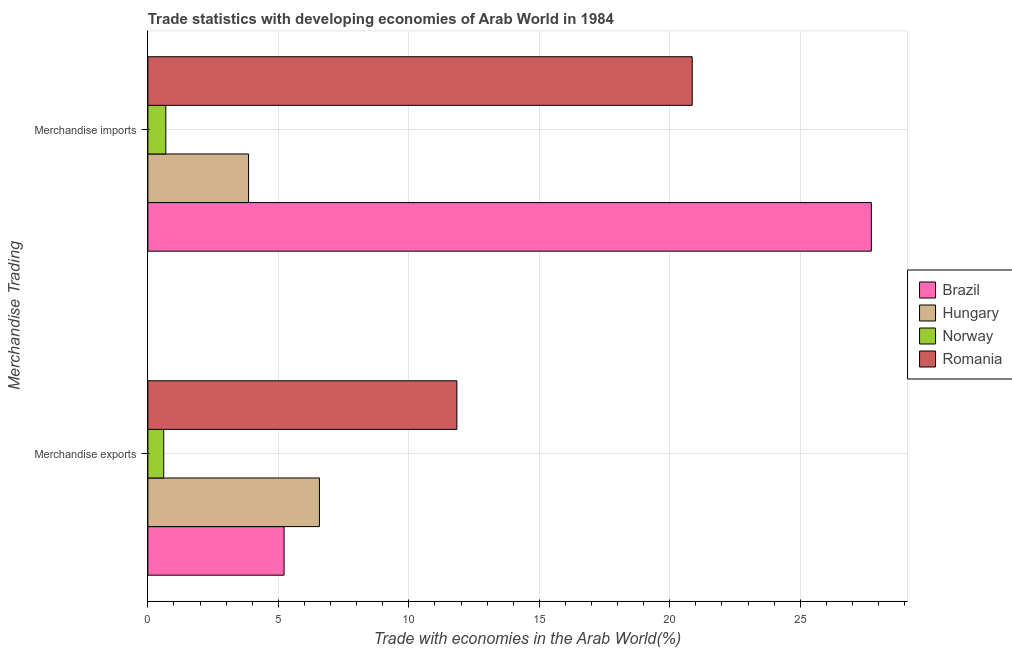How many different coloured bars are there?
Keep it short and to the point. 4. How many groups of bars are there?
Ensure brevity in your answer.  2. Are the number of bars on each tick of the Y-axis equal?
Give a very brief answer. Yes. How many bars are there on the 1st tick from the top?
Provide a succinct answer. 4. How many bars are there on the 1st tick from the bottom?
Provide a succinct answer. 4. What is the label of the 1st group of bars from the top?
Your answer should be very brief. Merchandise imports. What is the merchandise imports in Hungary?
Your answer should be very brief. 3.86. Across all countries, what is the maximum merchandise exports?
Your response must be concise. 11.84. Across all countries, what is the minimum merchandise exports?
Offer a terse response. 0.61. In which country was the merchandise imports maximum?
Offer a very short reply. Brazil. What is the total merchandise exports in the graph?
Keep it short and to the point. 24.25. What is the difference between the merchandise exports in Romania and that in Norway?
Your response must be concise. 11.23. What is the difference between the merchandise exports in Romania and the merchandise imports in Norway?
Make the answer very short. 11.16. What is the average merchandise exports per country?
Make the answer very short. 6.06. What is the difference between the merchandise exports and merchandise imports in Hungary?
Make the answer very short. 2.72. In how many countries, is the merchandise exports greater than 2 %?
Your answer should be very brief. 3. What is the ratio of the merchandise exports in Hungary to that in Brazil?
Ensure brevity in your answer.  1.26. In how many countries, is the merchandise exports greater than the average merchandise exports taken over all countries?
Offer a terse response. 2. What does the 2nd bar from the bottom in Merchandise exports represents?
Provide a succinct answer. Hungary. How many bars are there?
Your answer should be very brief. 8. How many countries are there in the graph?
Your answer should be very brief. 4. What is the difference between two consecutive major ticks on the X-axis?
Keep it short and to the point. 5. Are the values on the major ticks of X-axis written in scientific E-notation?
Your response must be concise. No. Does the graph contain any zero values?
Offer a very short reply. No. Does the graph contain grids?
Offer a very short reply. Yes. Where does the legend appear in the graph?
Offer a very short reply. Center right. How are the legend labels stacked?
Offer a terse response. Vertical. What is the title of the graph?
Your answer should be compact. Trade statistics with developing economies of Arab World in 1984. Does "Chile" appear as one of the legend labels in the graph?
Offer a very short reply. No. What is the label or title of the X-axis?
Keep it short and to the point. Trade with economies in the Arab World(%). What is the label or title of the Y-axis?
Provide a short and direct response. Merchandise Trading. What is the Trade with economies in the Arab World(%) of Brazil in Merchandise exports?
Your answer should be very brief. 5.22. What is the Trade with economies in the Arab World(%) of Hungary in Merchandise exports?
Your response must be concise. 6.57. What is the Trade with economies in the Arab World(%) of Norway in Merchandise exports?
Provide a succinct answer. 0.61. What is the Trade with economies in the Arab World(%) in Romania in Merchandise exports?
Your answer should be compact. 11.84. What is the Trade with economies in the Arab World(%) of Brazil in Merchandise imports?
Your answer should be very brief. 27.73. What is the Trade with economies in the Arab World(%) of Hungary in Merchandise imports?
Ensure brevity in your answer.  3.86. What is the Trade with economies in the Arab World(%) of Norway in Merchandise imports?
Your answer should be very brief. 0.69. What is the Trade with economies in the Arab World(%) in Romania in Merchandise imports?
Keep it short and to the point. 20.86. Across all Merchandise Trading, what is the maximum Trade with economies in the Arab World(%) in Brazil?
Your response must be concise. 27.73. Across all Merchandise Trading, what is the maximum Trade with economies in the Arab World(%) of Hungary?
Your response must be concise. 6.57. Across all Merchandise Trading, what is the maximum Trade with economies in the Arab World(%) of Norway?
Ensure brevity in your answer.  0.69. Across all Merchandise Trading, what is the maximum Trade with economies in the Arab World(%) in Romania?
Your answer should be compact. 20.86. Across all Merchandise Trading, what is the minimum Trade with economies in the Arab World(%) in Brazil?
Your response must be concise. 5.22. Across all Merchandise Trading, what is the minimum Trade with economies in the Arab World(%) of Hungary?
Give a very brief answer. 3.86. Across all Merchandise Trading, what is the minimum Trade with economies in the Arab World(%) of Norway?
Ensure brevity in your answer.  0.61. Across all Merchandise Trading, what is the minimum Trade with economies in the Arab World(%) of Romania?
Ensure brevity in your answer.  11.84. What is the total Trade with economies in the Arab World(%) of Brazil in the graph?
Your answer should be very brief. 32.95. What is the total Trade with economies in the Arab World(%) of Hungary in the graph?
Offer a terse response. 10.43. What is the total Trade with economies in the Arab World(%) in Norway in the graph?
Ensure brevity in your answer.  1.3. What is the total Trade with economies in the Arab World(%) of Romania in the graph?
Your answer should be compact. 32.7. What is the difference between the Trade with economies in the Arab World(%) of Brazil in Merchandise exports and that in Merchandise imports?
Make the answer very short. -22.51. What is the difference between the Trade with economies in the Arab World(%) of Hungary in Merchandise exports and that in Merchandise imports?
Offer a terse response. 2.72. What is the difference between the Trade with economies in the Arab World(%) of Norway in Merchandise exports and that in Merchandise imports?
Your response must be concise. -0.08. What is the difference between the Trade with economies in the Arab World(%) in Romania in Merchandise exports and that in Merchandise imports?
Make the answer very short. -9.02. What is the difference between the Trade with economies in the Arab World(%) of Brazil in Merchandise exports and the Trade with economies in the Arab World(%) of Hungary in Merchandise imports?
Keep it short and to the point. 1.36. What is the difference between the Trade with economies in the Arab World(%) of Brazil in Merchandise exports and the Trade with economies in the Arab World(%) of Norway in Merchandise imports?
Keep it short and to the point. 4.53. What is the difference between the Trade with economies in the Arab World(%) in Brazil in Merchandise exports and the Trade with economies in the Arab World(%) in Romania in Merchandise imports?
Make the answer very short. -15.64. What is the difference between the Trade with economies in the Arab World(%) in Hungary in Merchandise exports and the Trade with economies in the Arab World(%) in Norway in Merchandise imports?
Provide a short and direct response. 5.89. What is the difference between the Trade with economies in the Arab World(%) of Hungary in Merchandise exports and the Trade with economies in the Arab World(%) of Romania in Merchandise imports?
Offer a very short reply. -14.29. What is the difference between the Trade with economies in the Arab World(%) in Norway in Merchandise exports and the Trade with economies in the Arab World(%) in Romania in Merchandise imports?
Your answer should be compact. -20.25. What is the average Trade with economies in the Arab World(%) in Brazil per Merchandise Trading?
Your answer should be very brief. 16.47. What is the average Trade with economies in the Arab World(%) of Hungary per Merchandise Trading?
Provide a short and direct response. 5.22. What is the average Trade with economies in the Arab World(%) in Norway per Merchandise Trading?
Provide a succinct answer. 0.65. What is the average Trade with economies in the Arab World(%) of Romania per Merchandise Trading?
Make the answer very short. 16.35. What is the difference between the Trade with economies in the Arab World(%) in Brazil and Trade with economies in the Arab World(%) in Hungary in Merchandise exports?
Your answer should be compact. -1.36. What is the difference between the Trade with economies in the Arab World(%) of Brazil and Trade with economies in the Arab World(%) of Norway in Merchandise exports?
Offer a terse response. 4.61. What is the difference between the Trade with economies in the Arab World(%) of Brazil and Trade with economies in the Arab World(%) of Romania in Merchandise exports?
Your answer should be compact. -6.62. What is the difference between the Trade with economies in the Arab World(%) in Hungary and Trade with economies in the Arab World(%) in Norway in Merchandise exports?
Keep it short and to the point. 5.97. What is the difference between the Trade with economies in the Arab World(%) of Hungary and Trade with economies in the Arab World(%) of Romania in Merchandise exports?
Keep it short and to the point. -5.27. What is the difference between the Trade with economies in the Arab World(%) of Norway and Trade with economies in the Arab World(%) of Romania in Merchandise exports?
Offer a terse response. -11.23. What is the difference between the Trade with economies in the Arab World(%) of Brazil and Trade with economies in the Arab World(%) of Hungary in Merchandise imports?
Ensure brevity in your answer.  23.87. What is the difference between the Trade with economies in the Arab World(%) of Brazil and Trade with economies in the Arab World(%) of Norway in Merchandise imports?
Keep it short and to the point. 27.04. What is the difference between the Trade with economies in the Arab World(%) of Brazil and Trade with economies in the Arab World(%) of Romania in Merchandise imports?
Ensure brevity in your answer.  6.87. What is the difference between the Trade with economies in the Arab World(%) of Hungary and Trade with economies in the Arab World(%) of Norway in Merchandise imports?
Keep it short and to the point. 3.17. What is the difference between the Trade with economies in the Arab World(%) of Hungary and Trade with economies in the Arab World(%) of Romania in Merchandise imports?
Make the answer very short. -17. What is the difference between the Trade with economies in the Arab World(%) of Norway and Trade with economies in the Arab World(%) of Romania in Merchandise imports?
Ensure brevity in your answer.  -20.17. What is the ratio of the Trade with economies in the Arab World(%) in Brazil in Merchandise exports to that in Merchandise imports?
Provide a succinct answer. 0.19. What is the ratio of the Trade with economies in the Arab World(%) of Hungary in Merchandise exports to that in Merchandise imports?
Offer a very short reply. 1.7. What is the ratio of the Trade with economies in the Arab World(%) of Norway in Merchandise exports to that in Merchandise imports?
Offer a terse response. 0.88. What is the ratio of the Trade with economies in the Arab World(%) of Romania in Merchandise exports to that in Merchandise imports?
Offer a very short reply. 0.57. What is the difference between the highest and the second highest Trade with economies in the Arab World(%) in Brazil?
Provide a short and direct response. 22.51. What is the difference between the highest and the second highest Trade with economies in the Arab World(%) of Hungary?
Keep it short and to the point. 2.72. What is the difference between the highest and the second highest Trade with economies in the Arab World(%) in Norway?
Offer a very short reply. 0.08. What is the difference between the highest and the second highest Trade with economies in the Arab World(%) in Romania?
Offer a very short reply. 9.02. What is the difference between the highest and the lowest Trade with economies in the Arab World(%) of Brazil?
Make the answer very short. 22.51. What is the difference between the highest and the lowest Trade with economies in the Arab World(%) in Hungary?
Your response must be concise. 2.72. What is the difference between the highest and the lowest Trade with economies in the Arab World(%) of Norway?
Keep it short and to the point. 0.08. What is the difference between the highest and the lowest Trade with economies in the Arab World(%) of Romania?
Make the answer very short. 9.02. 